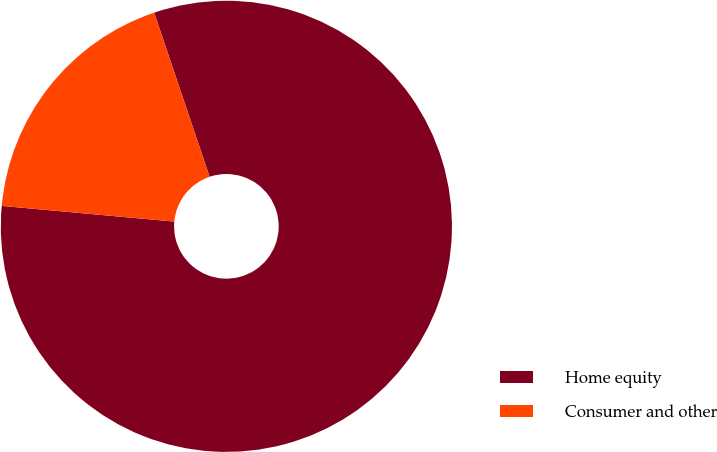Convert chart. <chart><loc_0><loc_0><loc_500><loc_500><pie_chart><fcel>Home equity<fcel>Consumer and other<nl><fcel>81.63%<fcel>18.37%<nl></chart> 